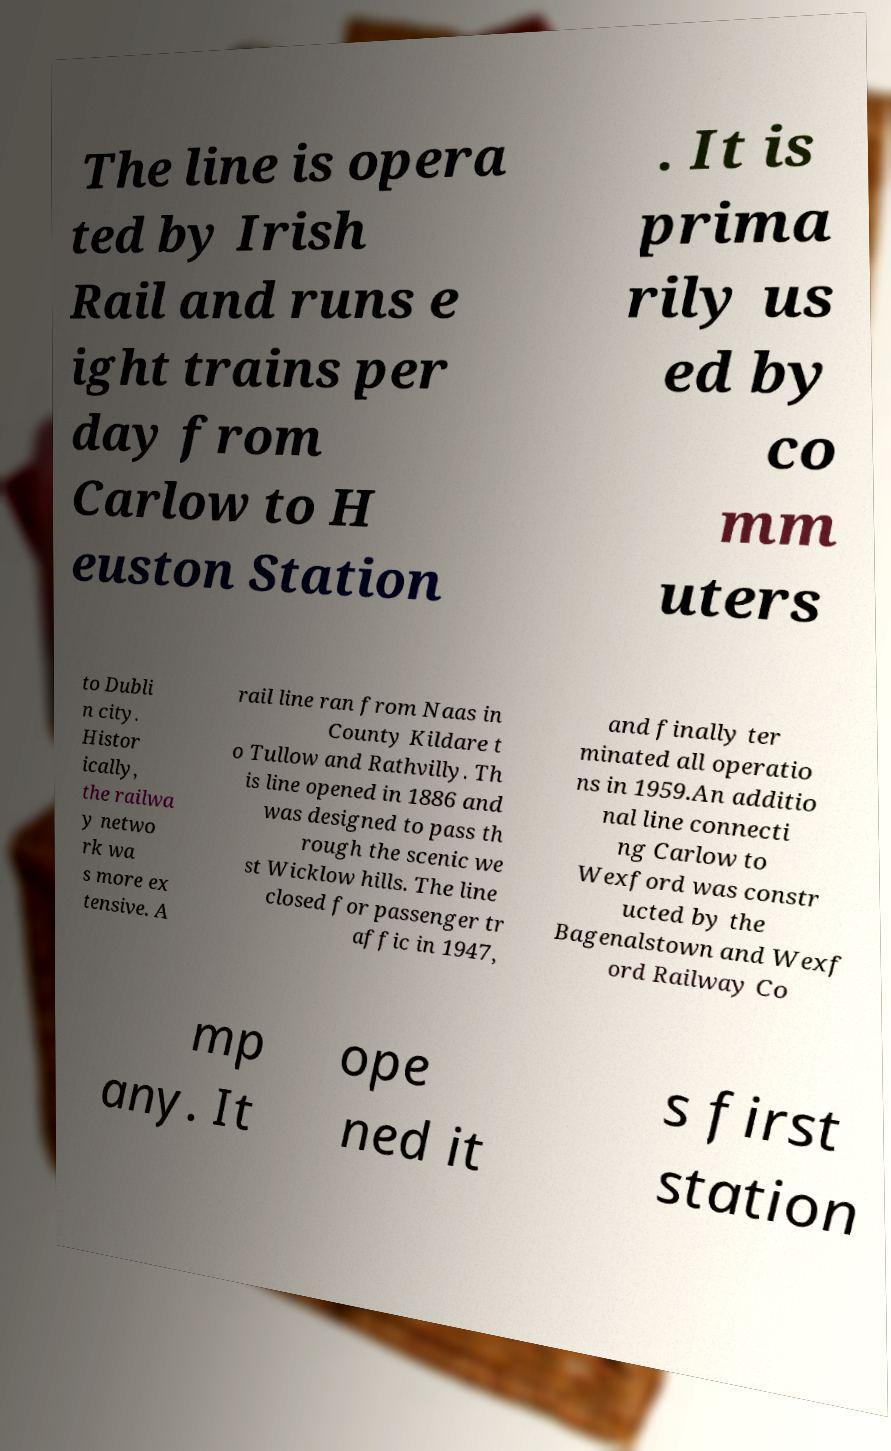There's text embedded in this image that I need extracted. Can you transcribe it verbatim? The line is opera ted by Irish Rail and runs e ight trains per day from Carlow to H euston Station . It is prima rily us ed by co mm uters to Dubli n city. Histor ically, the railwa y netwo rk wa s more ex tensive. A rail line ran from Naas in County Kildare t o Tullow and Rathvilly. Th is line opened in 1886 and was designed to pass th rough the scenic we st Wicklow hills. The line closed for passenger tr affic in 1947, and finally ter minated all operatio ns in 1959.An additio nal line connecti ng Carlow to Wexford was constr ucted by the Bagenalstown and Wexf ord Railway Co mp any. It ope ned it s first station 